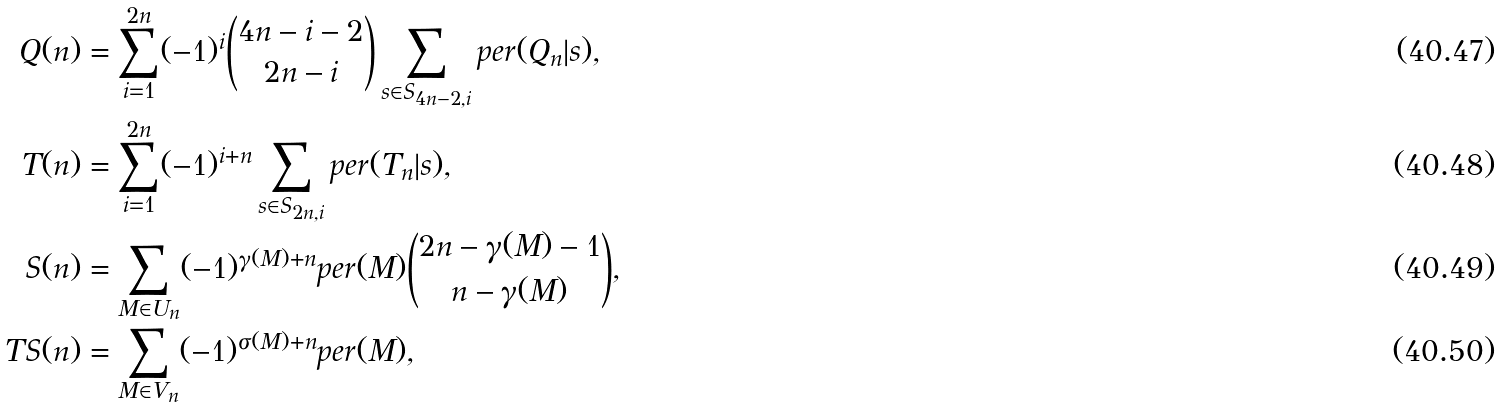<formula> <loc_0><loc_0><loc_500><loc_500>Q ( n ) & = \sum _ { i = 1 } ^ { 2 n } ( - 1 ) ^ { i } \binom { 4 n - i - 2 } { 2 n - i } \sum _ { s \in S _ { 4 n - 2 , i } } p e r ( Q _ { n } | s ) , \\ T ( n ) & = \sum _ { i = 1 } ^ { 2 n } ( - 1 ) ^ { i + n } \sum _ { s \in S _ { 2 n , i } } p e r ( T _ { n } | s ) , \\ S ( n ) & = \sum _ { M \in U _ { n } } ( - 1 ) ^ { \gamma ( M ) + n } p e r ( M ) \binom { 2 n - \gamma ( M ) - 1 } { n - \gamma ( M ) } , \\ T S ( n ) & = \sum _ { M \in V _ { n } } ( - 1 ) ^ { \sigma ( M ) + n } p e r ( M ) ,</formula> 